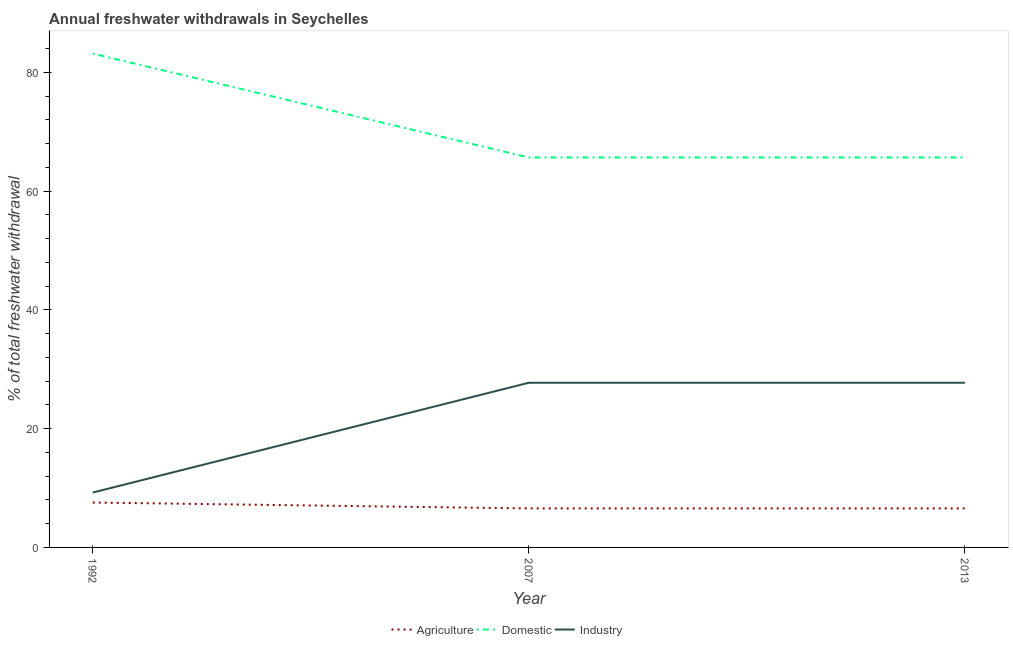How many different coloured lines are there?
Offer a terse response. 3. Does the line corresponding to percentage of freshwater withdrawal for agriculture intersect with the line corresponding to percentage of freshwater withdrawal for industry?
Ensure brevity in your answer.  No. What is the percentage of freshwater withdrawal for domestic purposes in 1992?
Your answer should be compact. 83.19. Across all years, what is the maximum percentage of freshwater withdrawal for domestic purposes?
Provide a succinct answer. 83.19. Across all years, what is the minimum percentage of freshwater withdrawal for domestic purposes?
Keep it short and to the point. 65.69. In which year was the percentage of freshwater withdrawal for agriculture minimum?
Your answer should be very brief. 2007. What is the total percentage of freshwater withdrawal for domestic purposes in the graph?
Your response must be concise. 214.57. What is the difference between the percentage of freshwater withdrawal for industry in 1992 and that in 2013?
Provide a short and direct response. -18.5. What is the difference between the percentage of freshwater withdrawal for industry in 2013 and the percentage of freshwater withdrawal for domestic purposes in 2007?
Your answer should be very brief. -37.95. What is the average percentage of freshwater withdrawal for agriculture per year?
Provide a succinct answer. 6.9. In the year 2013, what is the difference between the percentage of freshwater withdrawal for domestic purposes and percentage of freshwater withdrawal for industry?
Give a very brief answer. 37.95. What is the ratio of the percentage of freshwater withdrawal for domestic purposes in 1992 to that in 2007?
Provide a short and direct response. 1.27. Is the percentage of freshwater withdrawal for agriculture in 2007 less than that in 2013?
Ensure brevity in your answer.  No. Is the difference between the percentage of freshwater withdrawal for domestic purposes in 1992 and 2013 greater than the difference between the percentage of freshwater withdrawal for agriculture in 1992 and 2013?
Keep it short and to the point. Yes. Is it the case that in every year, the sum of the percentage of freshwater withdrawal for agriculture and percentage of freshwater withdrawal for domestic purposes is greater than the percentage of freshwater withdrawal for industry?
Offer a very short reply. Yes. How many years are there in the graph?
Your answer should be very brief. 3. Are the values on the major ticks of Y-axis written in scientific E-notation?
Keep it short and to the point. No. Does the graph contain any zero values?
Your response must be concise. No. Does the graph contain grids?
Give a very brief answer. No. Where does the legend appear in the graph?
Offer a very short reply. Bottom center. How many legend labels are there?
Keep it short and to the point. 3. What is the title of the graph?
Provide a succinct answer. Annual freshwater withdrawals in Seychelles. What is the label or title of the X-axis?
Make the answer very short. Year. What is the label or title of the Y-axis?
Ensure brevity in your answer.  % of total freshwater withdrawal. What is the % of total freshwater withdrawal in Agriculture in 1992?
Provide a short and direct response. 7.56. What is the % of total freshwater withdrawal in Domestic in 1992?
Offer a terse response. 83.19. What is the % of total freshwater withdrawal in Industry in 1992?
Provide a succinct answer. 9.24. What is the % of total freshwater withdrawal of Agriculture in 2007?
Your answer should be compact. 6.57. What is the % of total freshwater withdrawal of Domestic in 2007?
Make the answer very short. 65.69. What is the % of total freshwater withdrawal in Industry in 2007?
Ensure brevity in your answer.  27.74. What is the % of total freshwater withdrawal of Agriculture in 2013?
Your answer should be compact. 6.57. What is the % of total freshwater withdrawal of Domestic in 2013?
Make the answer very short. 65.69. What is the % of total freshwater withdrawal in Industry in 2013?
Keep it short and to the point. 27.74. Across all years, what is the maximum % of total freshwater withdrawal of Agriculture?
Keep it short and to the point. 7.56. Across all years, what is the maximum % of total freshwater withdrawal in Domestic?
Your response must be concise. 83.19. Across all years, what is the maximum % of total freshwater withdrawal of Industry?
Provide a succinct answer. 27.74. Across all years, what is the minimum % of total freshwater withdrawal in Agriculture?
Make the answer very short. 6.57. Across all years, what is the minimum % of total freshwater withdrawal of Domestic?
Offer a very short reply. 65.69. Across all years, what is the minimum % of total freshwater withdrawal of Industry?
Offer a terse response. 9.24. What is the total % of total freshwater withdrawal in Agriculture in the graph?
Your answer should be compact. 20.7. What is the total % of total freshwater withdrawal in Domestic in the graph?
Make the answer very short. 214.57. What is the total % of total freshwater withdrawal in Industry in the graph?
Your response must be concise. 64.72. What is the difference between the % of total freshwater withdrawal in Domestic in 1992 and that in 2007?
Your answer should be very brief. 17.5. What is the difference between the % of total freshwater withdrawal in Industry in 1992 and that in 2007?
Provide a succinct answer. -18.5. What is the difference between the % of total freshwater withdrawal in Agriculture in 1992 and that in 2013?
Give a very brief answer. 0.99. What is the difference between the % of total freshwater withdrawal in Industry in 1992 and that in 2013?
Offer a very short reply. -18.5. What is the difference between the % of total freshwater withdrawal in Agriculture in 2007 and that in 2013?
Offer a terse response. 0. What is the difference between the % of total freshwater withdrawal of Domestic in 2007 and that in 2013?
Your answer should be very brief. 0. What is the difference between the % of total freshwater withdrawal of Industry in 2007 and that in 2013?
Make the answer very short. 0. What is the difference between the % of total freshwater withdrawal of Agriculture in 1992 and the % of total freshwater withdrawal of Domestic in 2007?
Ensure brevity in your answer.  -58.13. What is the difference between the % of total freshwater withdrawal of Agriculture in 1992 and the % of total freshwater withdrawal of Industry in 2007?
Give a very brief answer. -20.18. What is the difference between the % of total freshwater withdrawal in Domestic in 1992 and the % of total freshwater withdrawal in Industry in 2007?
Make the answer very short. 55.45. What is the difference between the % of total freshwater withdrawal of Agriculture in 1992 and the % of total freshwater withdrawal of Domestic in 2013?
Ensure brevity in your answer.  -58.13. What is the difference between the % of total freshwater withdrawal of Agriculture in 1992 and the % of total freshwater withdrawal of Industry in 2013?
Give a very brief answer. -20.18. What is the difference between the % of total freshwater withdrawal in Domestic in 1992 and the % of total freshwater withdrawal in Industry in 2013?
Keep it short and to the point. 55.45. What is the difference between the % of total freshwater withdrawal of Agriculture in 2007 and the % of total freshwater withdrawal of Domestic in 2013?
Make the answer very short. -59.12. What is the difference between the % of total freshwater withdrawal of Agriculture in 2007 and the % of total freshwater withdrawal of Industry in 2013?
Provide a short and direct response. -21.17. What is the difference between the % of total freshwater withdrawal in Domestic in 2007 and the % of total freshwater withdrawal in Industry in 2013?
Offer a very short reply. 37.95. What is the average % of total freshwater withdrawal in Agriculture per year?
Provide a short and direct response. 6.9. What is the average % of total freshwater withdrawal in Domestic per year?
Offer a very short reply. 71.52. What is the average % of total freshwater withdrawal of Industry per year?
Provide a succinct answer. 21.57. In the year 1992, what is the difference between the % of total freshwater withdrawal in Agriculture and % of total freshwater withdrawal in Domestic?
Offer a terse response. -75.63. In the year 1992, what is the difference between the % of total freshwater withdrawal in Agriculture and % of total freshwater withdrawal in Industry?
Your answer should be very brief. -1.68. In the year 1992, what is the difference between the % of total freshwater withdrawal in Domestic and % of total freshwater withdrawal in Industry?
Make the answer very short. 73.95. In the year 2007, what is the difference between the % of total freshwater withdrawal in Agriculture and % of total freshwater withdrawal in Domestic?
Make the answer very short. -59.12. In the year 2007, what is the difference between the % of total freshwater withdrawal of Agriculture and % of total freshwater withdrawal of Industry?
Provide a succinct answer. -21.17. In the year 2007, what is the difference between the % of total freshwater withdrawal in Domestic and % of total freshwater withdrawal in Industry?
Provide a succinct answer. 37.95. In the year 2013, what is the difference between the % of total freshwater withdrawal in Agriculture and % of total freshwater withdrawal in Domestic?
Make the answer very short. -59.12. In the year 2013, what is the difference between the % of total freshwater withdrawal in Agriculture and % of total freshwater withdrawal in Industry?
Offer a very short reply. -21.17. In the year 2013, what is the difference between the % of total freshwater withdrawal of Domestic and % of total freshwater withdrawal of Industry?
Offer a very short reply. 37.95. What is the ratio of the % of total freshwater withdrawal in Agriculture in 1992 to that in 2007?
Your answer should be compact. 1.15. What is the ratio of the % of total freshwater withdrawal in Domestic in 1992 to that in 2007?
Offer a very short reply. 1.27. What is the ratio of the % of total freshwater withdrawal in Industry in 1992 to that in 2007?
Your answer should be very brief. 0.33. What is the ratio of the % of total freshwater withdrawal of Agriculture in 1992 to that in 2013?
Keep it short and to the point. 1.15. What is the ratio of the % of total freshwater withdrawal of Domestic in 1992 to that in 2013?
Provide a short and direct response. 1.27. What is the ratio of the % of total freshwater withdrawal of Industry in 1992 to that in 2013?
Your response must be concise. 0.33. What is the ratio of the % of total freshwater withdrawal of Agriculture in 2007 to that in 2013?
Your response must be concise. 1. What is the ratio of the % of total freshwater withdrawal in Industry in 2007 to that in 2013?
Provide a succinct answer. 1. What is the difference between the highest and the lowest % of total freshwater withdrawal of Agriculture?
Your answer should be compact. 0.99. What is the difference between the highest and the lowest % of total freshwater withdrawal of Industry?
Give a very brief answer. 18.5. 